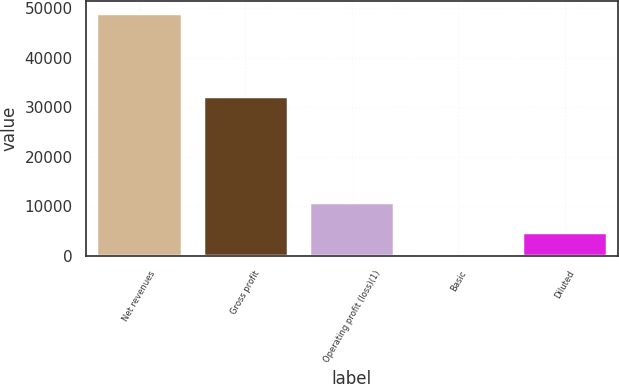Convert chart to OTSL. <chart><loc_0><loc_0><loc_500><loc_500><bar_chart><fcel>Net revenues<fcel>Gross profit<fcel>Operating profit (loss)(1)<fcel>Basic<fcel>Diluted<nl><fcel>49034<fcel>32245<fcel>10965<fcel>0.16<fcel>4903.54<nl></chart> 